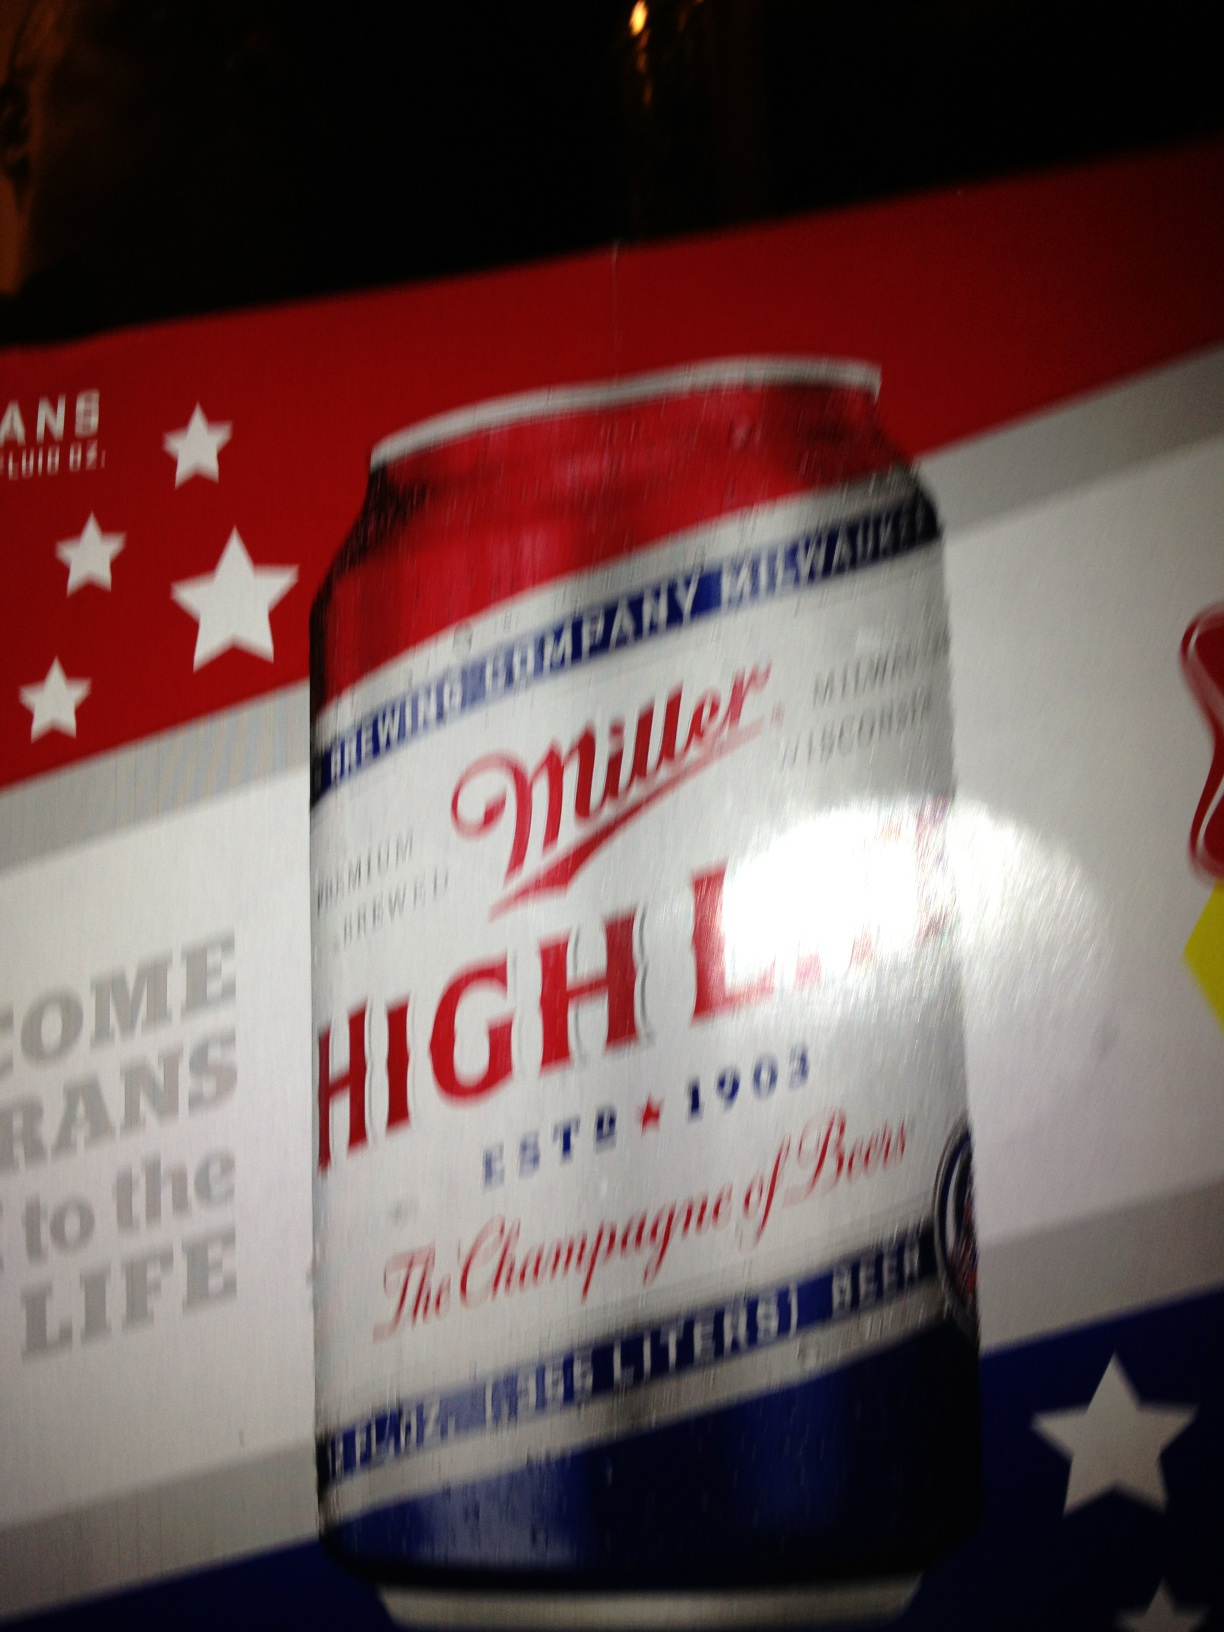What might be the occasion for enjoying this beer? Miller High Life is a versatile beer that fits many occasions, from casual get-togethers to celebrating milestones. Its ease of drinking makes it perfect for barbecues, sporting events, or simply enjoying a quiet moment at home. Is there anything distinctive about the taste? Yes, Miller High Life has a crisp, smooth taste with a slightly sweet finish. The beer is characterized by its light body and moderate hop bitterness, making it a refreshing choice for many beer drinkers. 